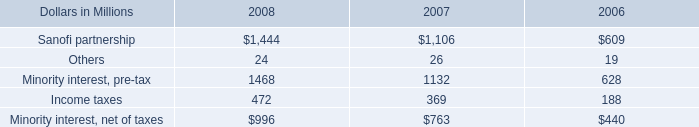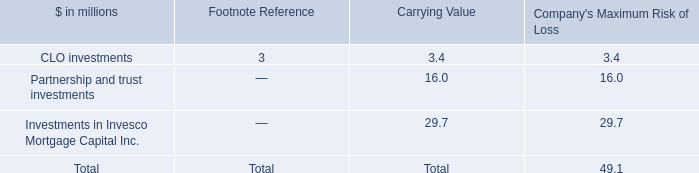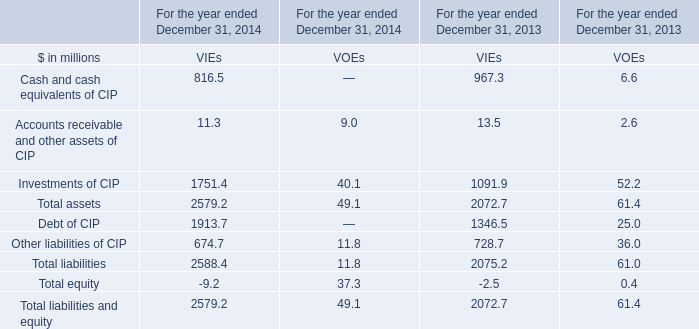How many elements show negative value in2014 forVIEs ? 
Answer: 1. What is the sum of Total assets of VIEs in 2013 and Minority interest, pre-tax in 2007? (in million) 
Computations: (2072.7 + 1132)
Answer: 3204.7. 